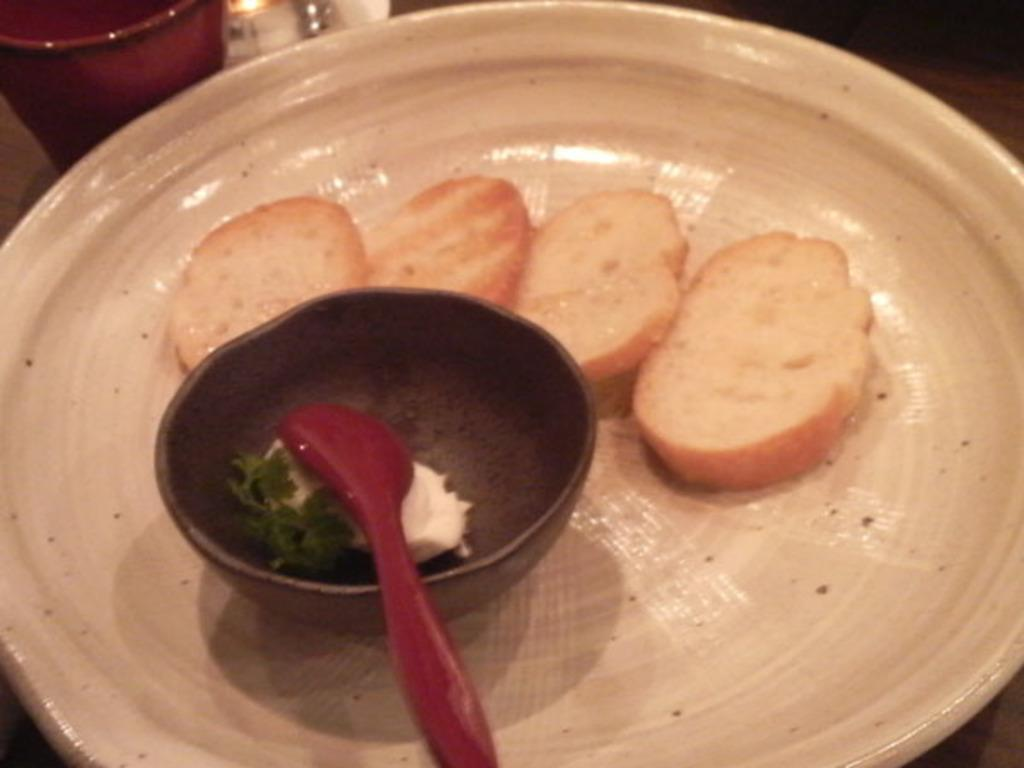What is on the plate in the image? The plate contains a food item that is cream and brown in color. What can be used to eat the food item on the plate? There is a spoon in the image that can be used to eat the food item. What else is present in the image besides the plate and spoon? There is a bowl and other unspecified objects in the image. What type of caption is written on the plate in the image? There is no caption written on the plate in the image; it is a plate with a food item. What material is the spoon made of, and is it shiny or dull? The material of the spoon is not specified in the image, and there is no information about its shine or dullness. 